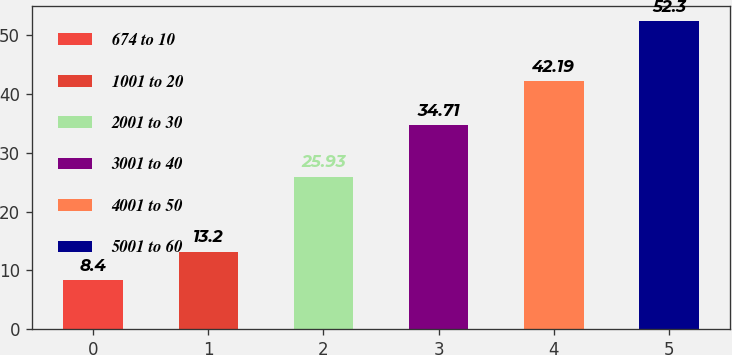<chart> <loc_0><loc_0><loc_500><loc_500><bar_chart><fcel>674 to 10<fcel>1001 to 20<fcel>2001 to 30<fcel>3001 to 40<fcel>4001 to 50<fcel>5001 to 60<nl><fcel>8.4<fcel>13.2<fcel>25.93<fcel>34.71<fcel>42.19<fcel>52.3<nl></chart> 